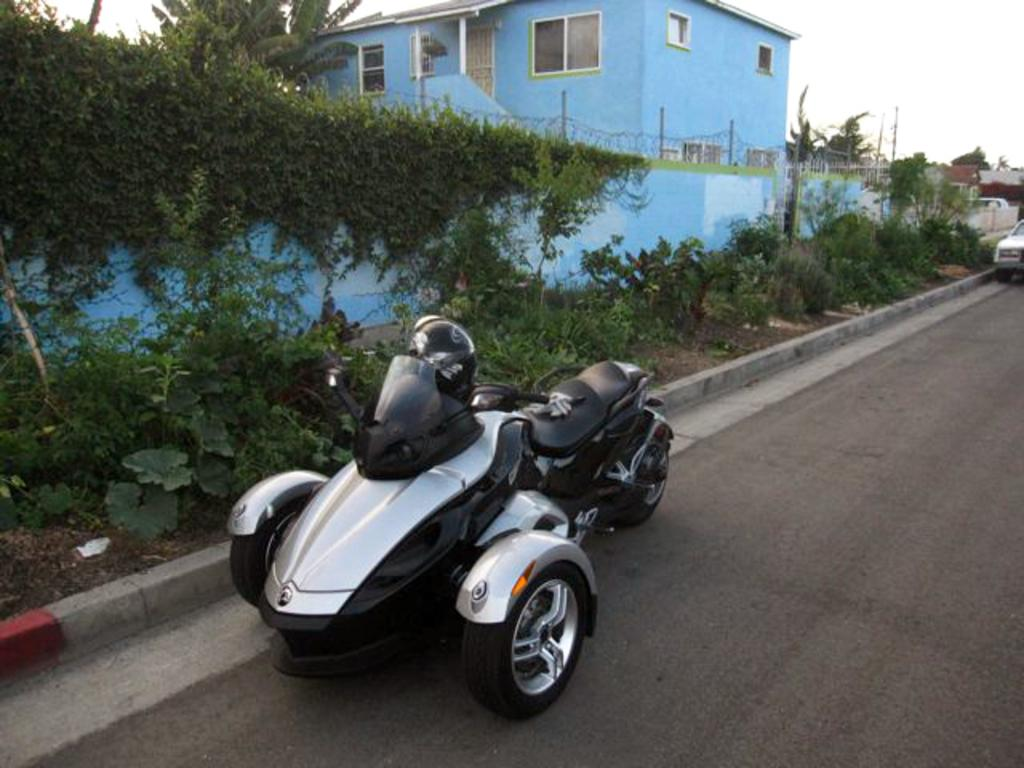How many vehicles can be seen on the road in the image? There are 2 vehicles on the road in the image. What type of vegetation is visible in the image? There are plants and trees visible in the image. What is growing on the wall in the image? There are creepers growing on a wall in the image. What can be seen in the background of the image? There are buildings, trees, and the sky visible in the background of the image. Where is the scarecrow placed in the image? There is no scarecrow present in the image. What type of oil is being used to maintain the vehicles in the image? There is no mention of oil or vehicle maintenance in the image. 